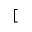<formula> <loc_0><loc_0><loc_500><loc_500>[</formula> 